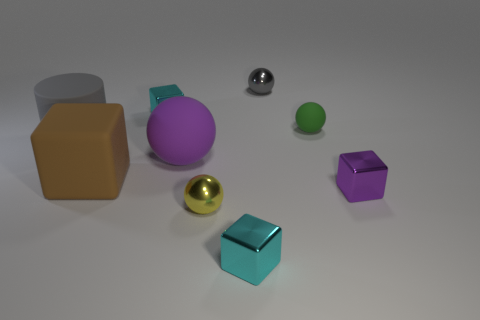Subtract all gray cylinders. How many cyan cubes are left? 2 Subtract all big brown cubes. How many cubes are left? 3 Add 1 small red matte balls. How many objects exist? 10 Subtract all purple blocks. How many blocks are left? 3 Subtract 2 blocks. How many blocks are left? 2 Subtract all cylinders. How many objects are left? 8 Subtract all brown blocks. Subtract all blue spheres. How many blocks are left? 3 Subtract all yellow shiny objects. Subtract all metal balls. How many objects are left? 6 Add 2 tiny shiny objects. How many tiny shiny objects are left? 7 Add 6 tiny red metallic cylinders. How many tiny red metallic cylinders exist? 6 